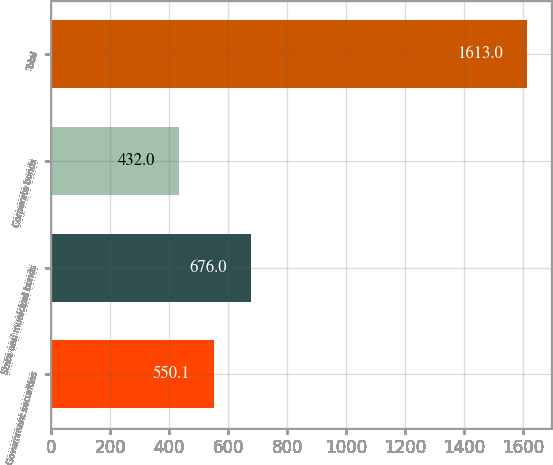Convert chart to OTSL. <chart><loc_0><loc_0><loc_500><loc_500><bar_chart><fcel>Government securities<fcel>State and municipal bonds<fcel>Corporate bonds<fcel>Total<nl><fcel>550.1<fcel>676<fcel>432<fcel>1613<nl></chart> 